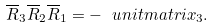<formula> <loc_0><loc_0><loc_500><loc_500>\overline { R } _ { 3 } \overline { R } _ { 2 } \overline { R } _ { 1 } = - \ u n i t m a t r i x _ { 3 } .</formula> 